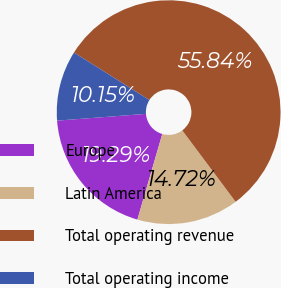<chart> <loc_0><loc_0><loc_500><loc_500><pie_chart><fcel>Europe<fcel>Latin America<fcel>Total operating revenue<fcel>Total operating income<nl><fcel>19.29%<fcel>14.72%<fcel>55.85%<fcel>10.15%<nl></chart> 